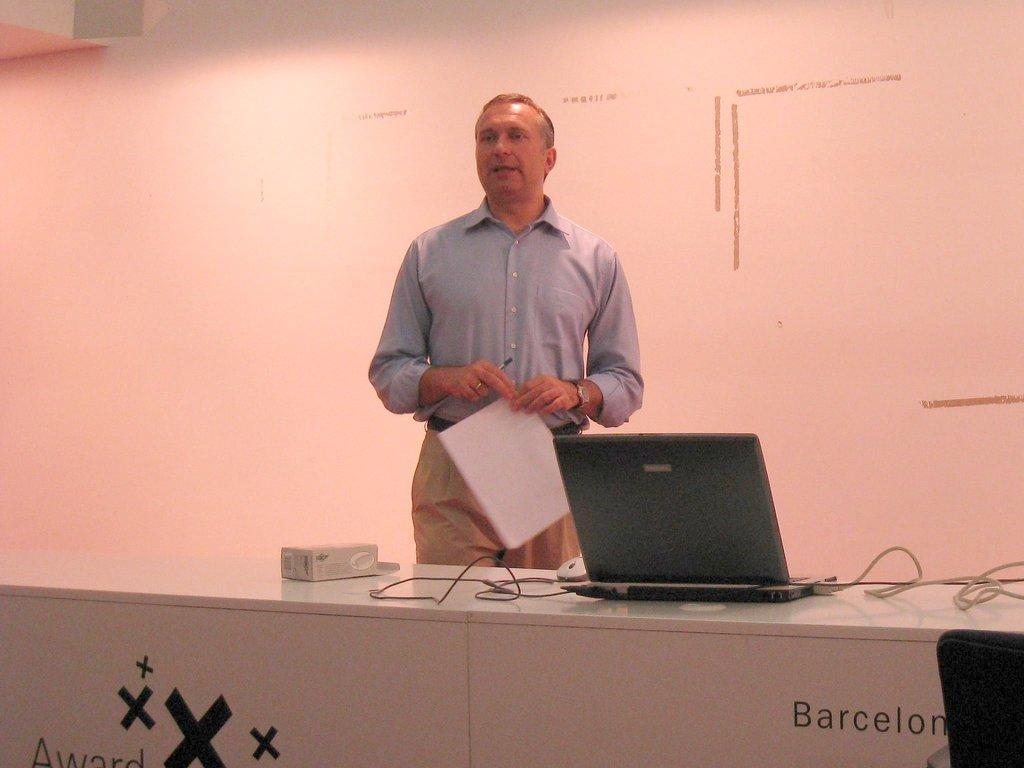Could you give a brief overview of what you see in this image? In this image we can see a man holding the paper and also the pen and standing. We can also see the table and on the table we can see a box, laptop, mouse and also the wires. In the background we can see the wall. 